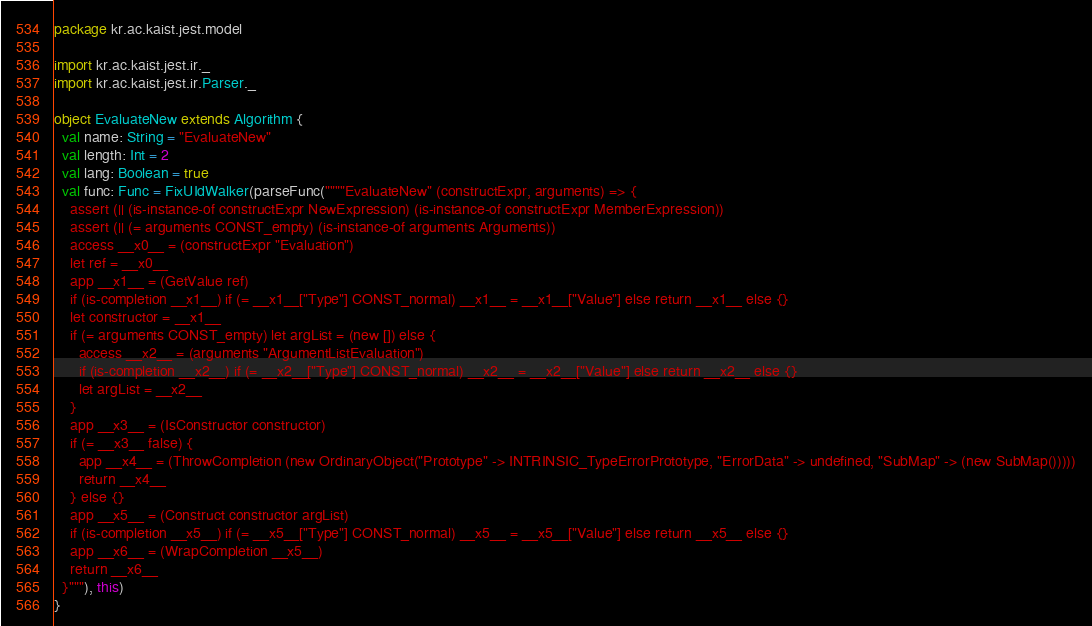<code> <loc_0><loc_0><loc_500><loc_500><_Scala_>package kr.ac.kaist.jest.model

import kr.ac.kaist.jest.ir._
import kr.ac.kaist.jest.ir.Parser._

object EvaluateNew extends Algorithm {
  val name: String = "EvaluateNew"
  val length: Int = 2
  val lang: Boolean = true
  val func: Func = FixUIdWalker(parseFunc(""""EvaluateNew" (constructExpr, arguments) => {
    assert (|| (is-instance-of constructExpr NewExpression) (is-instance-of constructExpr MemberExpression))
    assert (|| (= arguments CONST_empty) (is-instance-of arguments Arguments))
    access __x0__ = (constructExpr "Evaluation")
    let ref = __x0__
    app __x1__ = (GetValue ref)
    if (is-completion __x1__) if (= __x1__["Type"] CONST_normal) __x1__ = __x1__["Value"] else return __x1__ else {}
    let constructor = __x1__
    if (= arguments CONST_empty) let argList = (new []) else {
      access __x2__ = (arguments "ArgumentListEvaluation")
      if (is-completion __x2__) if (= __x2__["Type"] CONST_normal) __x2__ = __x2__["Value"] else return __x2__ else {}
      let argList = __x2__
    }
    app __x3__ = (IsConstructor constructor)
    if (= __x3__ false) {
      app __x4__ = (ThrowCompletion (new OrdinaryObject("Prototype" -> INTRINSIC_TypeErrorPrototype, "ErrorData" -> undefined, "SubMap" -> (new SubMap()))))
      return __x4__
    } else {}
    app __x5__ = (Construct constructor argList)
    if (is-completion __x5__) if (= __x5__["Type"] CONST_normal) __x5__ = __x5__["Value"] else return __x5__ else {}
    app __x6__ = (WrapCompletion __x5__)
    return __x6__
  }"""), this)
}
</code> 